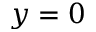Convert formula to latex. <formula><loc_0><loc_0><loc_500><loc_500>y = 0</formula> 